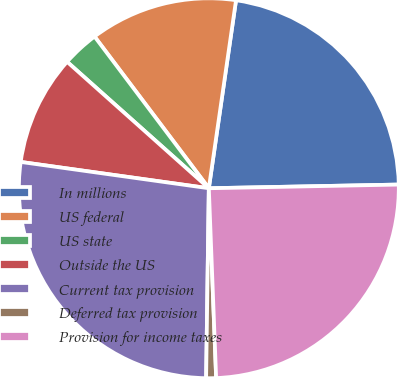<chart> <loc_0><loc_0><loc_500><loc_500><pie_chart><fcel>In millions<fcel>US federal<fcel>US state<fcel>Outside the US<fcel>Current tax provision<fcel>Deferred tax provision<fcel>Provision for income taxes<nl><fcel>22.4%<fcel>12.56%<fcel>3.13%<fcel>9.38%<fcel>26.98%<fcel>0.84%<fcel>24.69%<nl></chart> 